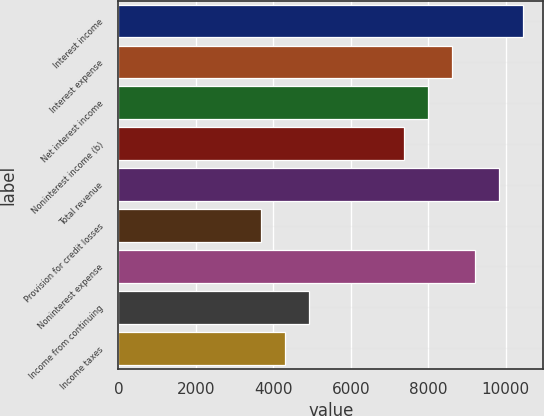Convert chart. <chart><loc_0><loc_0><loc_500><loc_500><bar_chart><fcel>Interest income<fcel>Interest expense<fcel>Net interest income<fcel>Noninterest income (b)<fcel>Total revenue<fcel>Provision for credit losses<fcel>Noninterest expense<fcel>Income from continuing<fcel>Income taxes<nl><fcel>10444.5<fcel>8601.42<fcel>7987.06<fcel>7372.7<fcel>9830.14<fcel>3686.54<fcel>9215.78<fcel>4915.26<fcel>4300.9<nl></chart> 